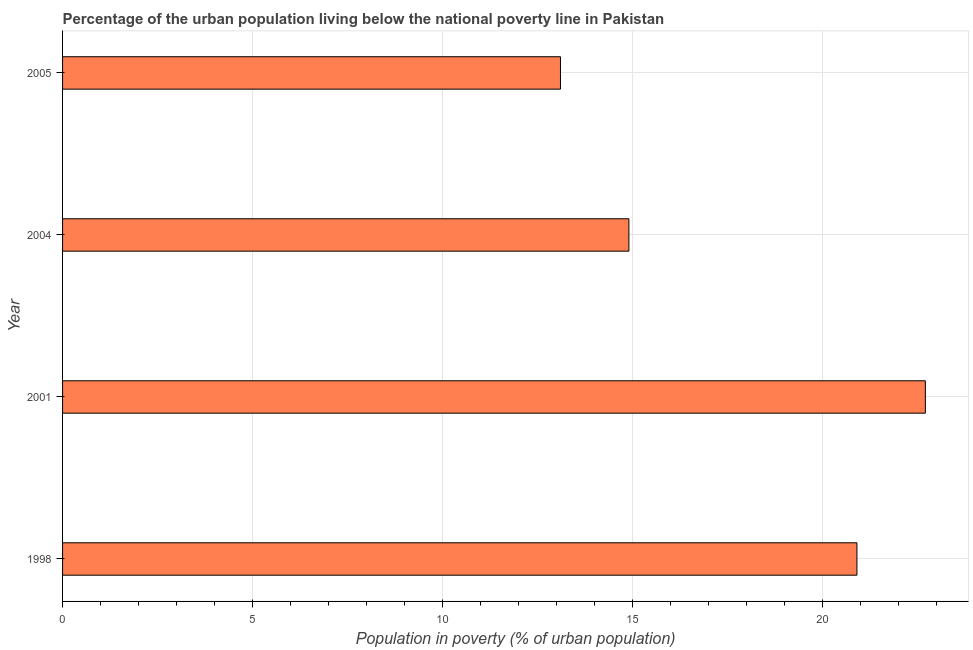Does the graph contain grids?
Your answer should be very brief. Yes. What is the title of the graph?
Provide a short and direct response. Percentage of the urban population living below the national poverty line in Pakistan. What is the label or title of the X-axis?
Your answer should be very brief. Population in poverty (% of urban population). Across all years, what is the maximum percentage of urban population living below poverty line?
Your answer should be very brief. 22.7. In which year was the percentage of urban population living below poverty line maximum?
Provide a succinct answer. 2001. In which year was the percentage of urban population living below poverty line minimum?
Offer a very short reply. 2005. What is the sum of the percentage of urban population living below poverty line?
Your response must be concise. 71.6. What is the difference between the percentage of urban population living below poverty line in 2001 and 2004?
Your answer should be very brief. 7.8. What is the average percentage of urban population living below poverty line per year?
Make the answer very short. 17.9. What is the median percentage of urban population living below poverty line?
Provide a succinct answer. 17.9. What is the ratio of the percentage of urban population living below poverty line in 1998 to that in 2005?
Provide a short and direct response. 1.59. Is the percentage of urban population living below poverty line in 1998 less than that in 2001?
Provide a succinct answer. Yes. What is the difference between the highest and the lowest percentage of urban population living below poverty line?
Make the answer very short. 9.6. Are all the bars in the graph horizontal?
Give a very brief answer. Yes. How many years are there in the graph?
Offer a very short reply. 4. What is the difference between two consecutive major ticks on the X-axis?
Your answer should be very brief. 5. Are the values on the major ticks of X-axis written in scientific E-notation?
Your answer should be compact. No. What is the Population in poverty (% of urban population) of 1998?
Offer a very short reply. 20.9. What is the Population in poverty (% of urban population) of 2001?
Make the answer very short. 22.7. What is the Population in poverty (% of urban population) in 2004?
Give a very brief answer. 14.9. What is the difference between the Population in poverty (% of urban population) in 1998 and 2001?
Provide a succinct answer. -1.8. What is the ratio of the Population in poverty (% of urban population) in 1998 to that in 2001?
Keep it short and to the point. 0.92. What is the ratio of the Population in poverty (% of urban population) in 1998 to that in 2004?
Your answer should be compact. 1.4. What is the ratio of the Population in poverty (% of urban population) in 1998 to that in 2005?
Your answer should be compact. 1.59. What is the ratio of the Population in poverty (% of urban population) in 2001 to that in 2004?
Keep it short and to the point. 1.52. What is the ratio of the Population in poverty (% of urban population) in 2001 to that in 2005?
Your answer should be compact. 1.73. What is the ratio of the Population in poverty (% of urban population) in 2004 to that in 2005?
Your response must be concise. 1.14. 